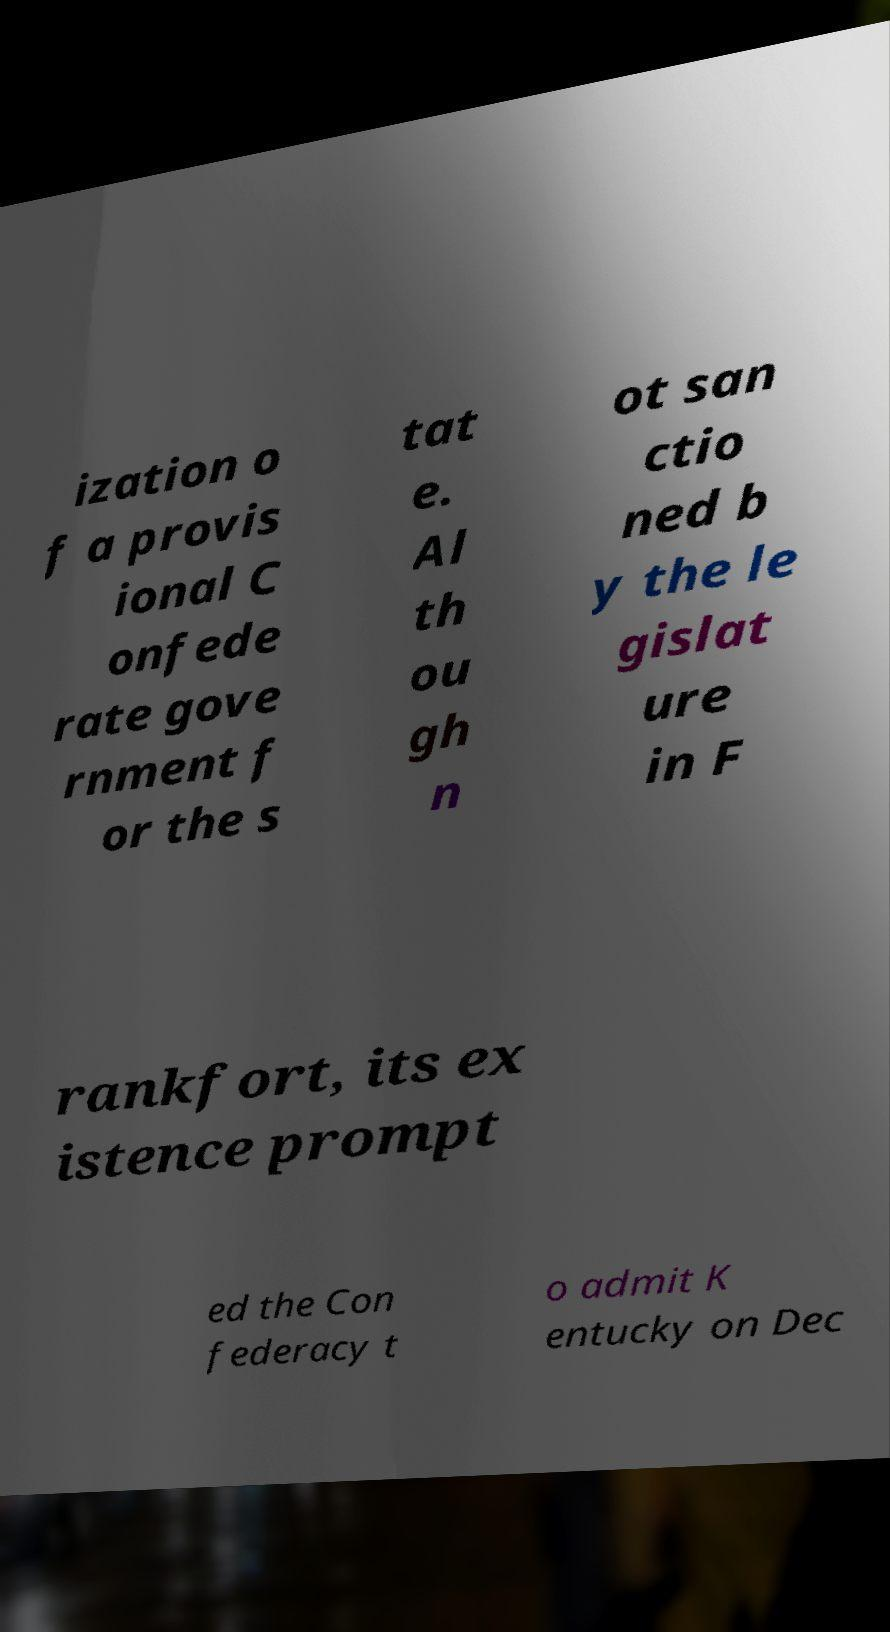Can you accurately transcribe the text from the provided image for me? ization o f a provis ional C onfede rate gove rnment f or the s tat e. Al th ou gh n ot san ctio ned b y the le gislat ure in F rankfort, its ex istence prompt ed the Con federacy t o admit K entucky on Dec 